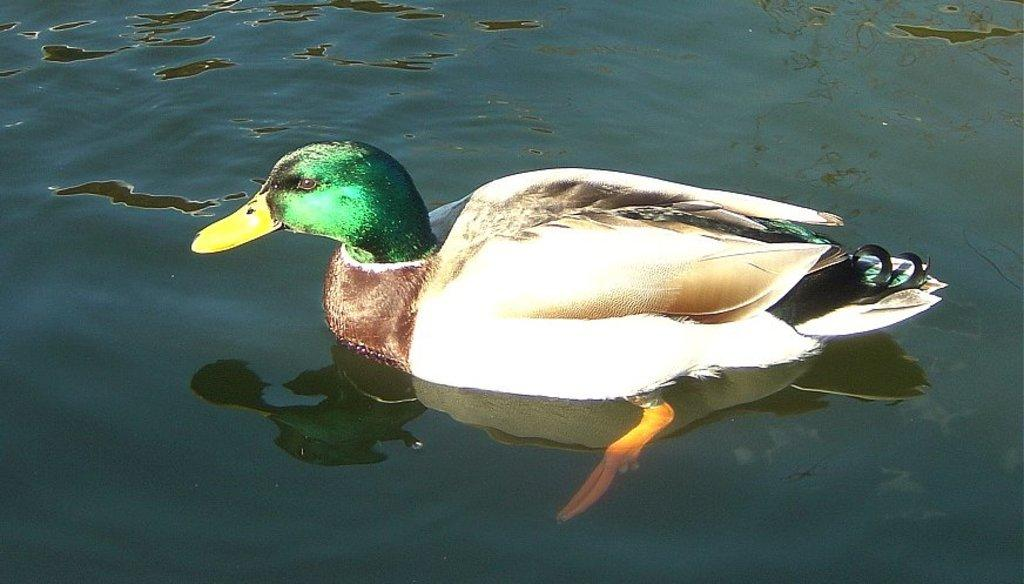What animal is present in the image? There is a duck in the image. Where is the duck located? The duck is on the water. Can you describe any additional features of the duck in the image? There is a reflection of the duck on the water. How fast is the duck running in the image? The duck is not running in the image; it is on the water. 